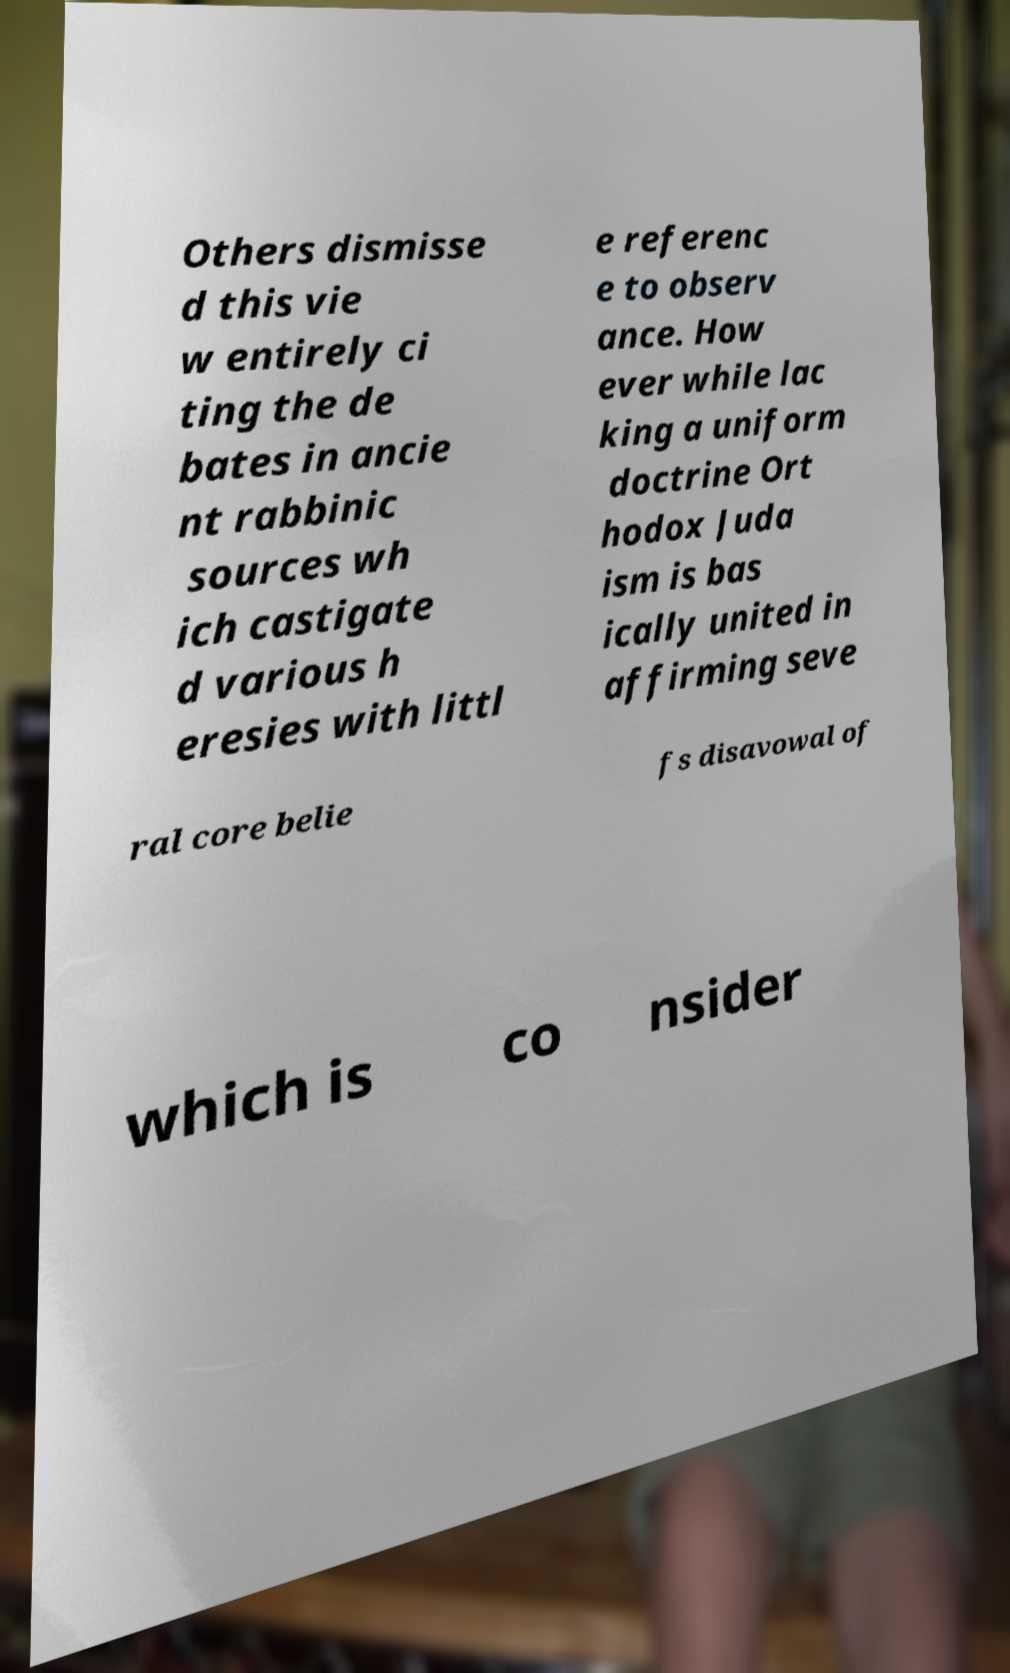I need the written content from this picture converted into text. Can you do that? Others dismisse d this vie w entirely ci ting the de bates in ancie nt rabbinic sources wh ich castigate d various h eresies with littl e referenc e to observ ance. How ever while lac king a uniform doctrine Ort hodox Juda ism is bas ically united in affirming seve ral core belie fs disavowal of which is co nsider 